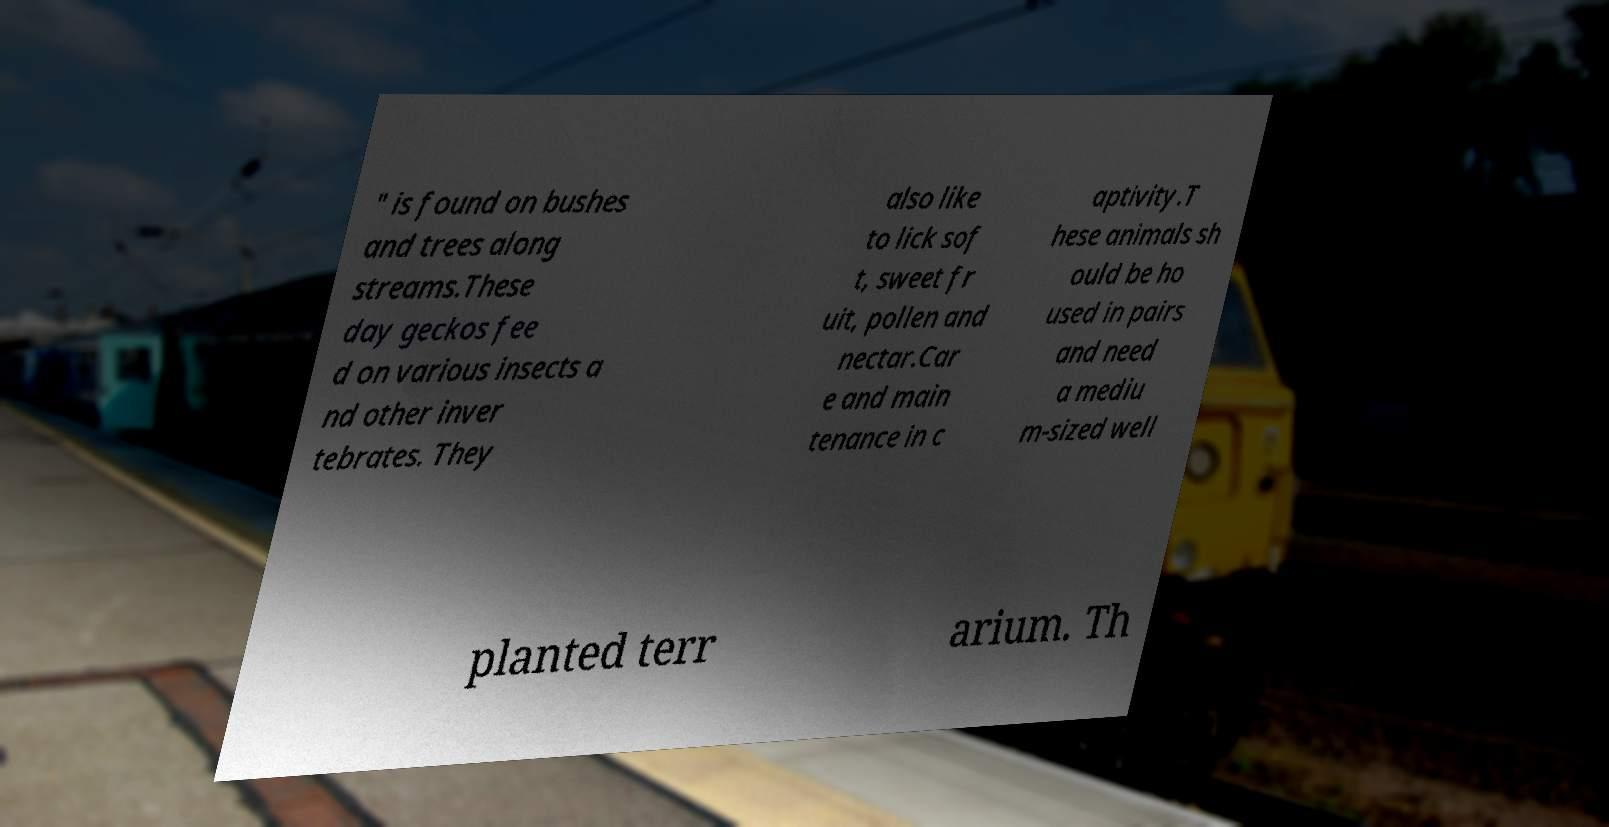Please read and relay the text visible in this image. What does it say? " is found on bushes and trees along streams.These day geckos fee d on various insects a nd other inver tebrates. They also like to lick sof t, sweet fr uit, pollen and nectar.Car e and main tenance in c aptivity.T hese animals sh ould be ho used in pairs and need a mediu m-sized well planted terr arium. Th 